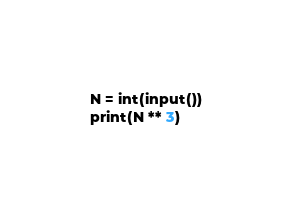Convert code to text. <code><loc_0><loc_0><loc_500><loc_500><_Python_>N = int(input())
print(N ** 3)</code> 